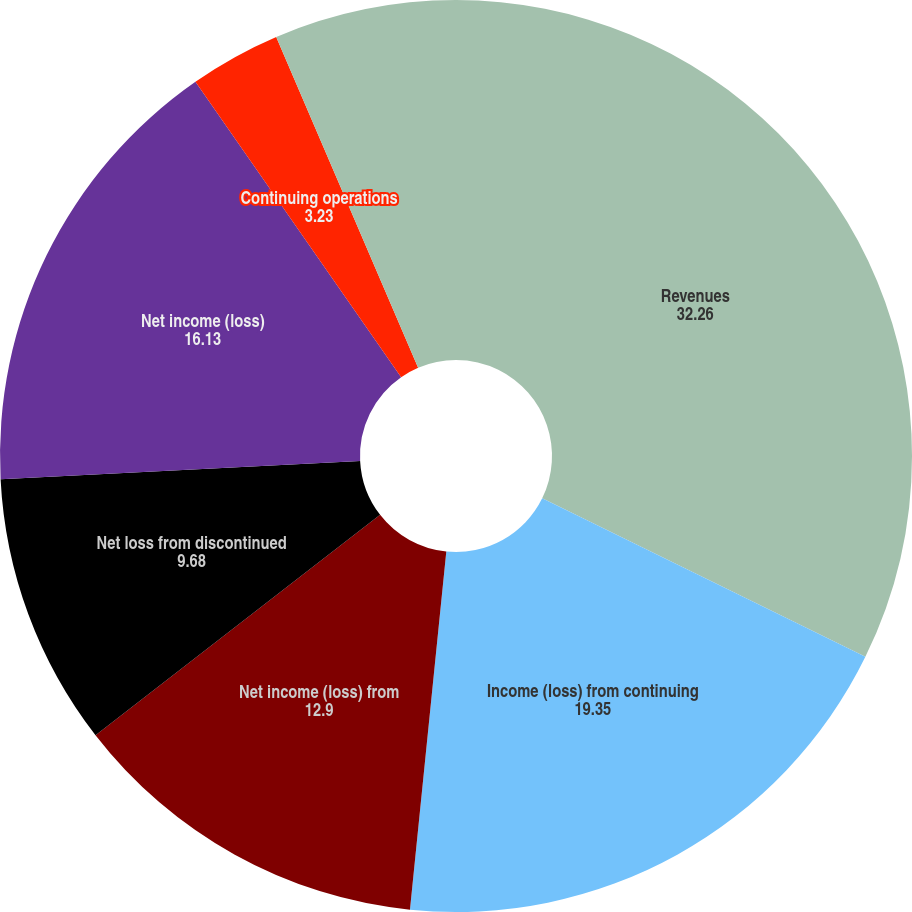<chart> <loc_0><loc_0><loc_500><loc_500><pie_chart><fcel>Revenues<fcel>Income (loss) from continuing<fcel>Net income (loss) from<fcel>Net loss from discontinued<fcel>Net income (loss)<fcel>Continuing operations<fcel>Consolidated<fcel>Dividends paid per share<nl><fcel>32.26%<fcel>19.35%<fcel>12.9%<fcel>9.68%<fcel>16.13%<fcel>3.23%<fcel>6.45%<fcel>0.0%<nl></chart> 